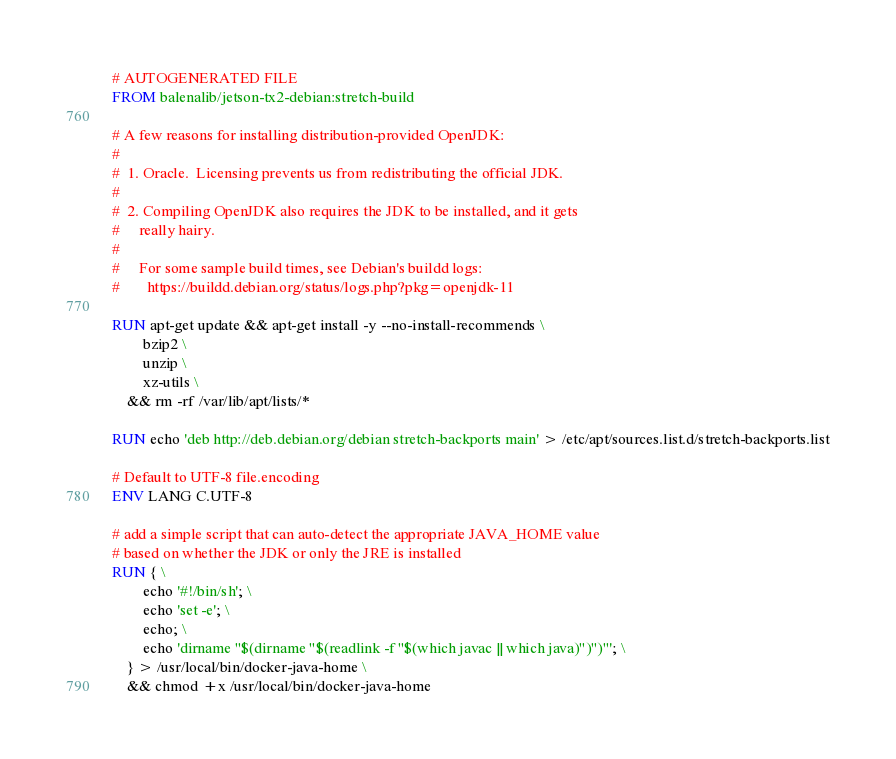Convert code to text. <code><loc_0><loc_0><loc_500><loc_500><_Dockerfile_># AUTOGENERATED FILE
FROM balenalib/jetson-tx2-debian:stretch-build

# A few reasons for installing distribution-provided OpenJDK:
#
#  1. Oracle.  Licensing prevents us from redistributing the official JDK.
#
#  2. Compiling OpenJDK also requires the JDK to be installed, and it gets
#     really hairy.
#
#     For some sample build times, see Debian's buildd logs:
#       https://buildd.debian.org/status/logs.php?pkg=openjdk-11

RUN apt-get update && apt-get install -y --no-install-recommends \
		bzip2 \
		unzip \
		xz-utils \
	&& rm -rf /var/lib/apt/lists/*

RUN echo 'deb http://deb.debian.org/debian stretch-backports main' > /etc/apt/sources.list.d/stretch-backports.list

# Default to UTF-8 file.encoding
ENV LANG C.UTF-8

# add a simple script that can auto-detect the appropriate JAVA_HOME value
# based on whether the JDK or only the JRE is installed
RUN { \
		echo '#!/bin/sh'; \
		echo 'set -e'; \
		echo; \
		echo 'dirname "$(dirname "$(readlink -f "$(which javac || which java)")")"'; \
	} > /usr/local/bin/docker-java-home \
	&& chmod +x /usr/local/bin/docker-java-home
</code> 